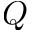Convert formula to latex. <formula><loc_0><loc_0><loc_500><loc_500>Q</formula> 